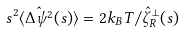<formula> <loc_0><loc_0><loc_500><loc_500>s ^ { 2 } \langle \hat { \Delta \psi ^ { 2 } } ( s ) \rangle = 2 k _ { B } T / \hat { \zeta } _ { R } ^ { \bot } ( s )</formula> 